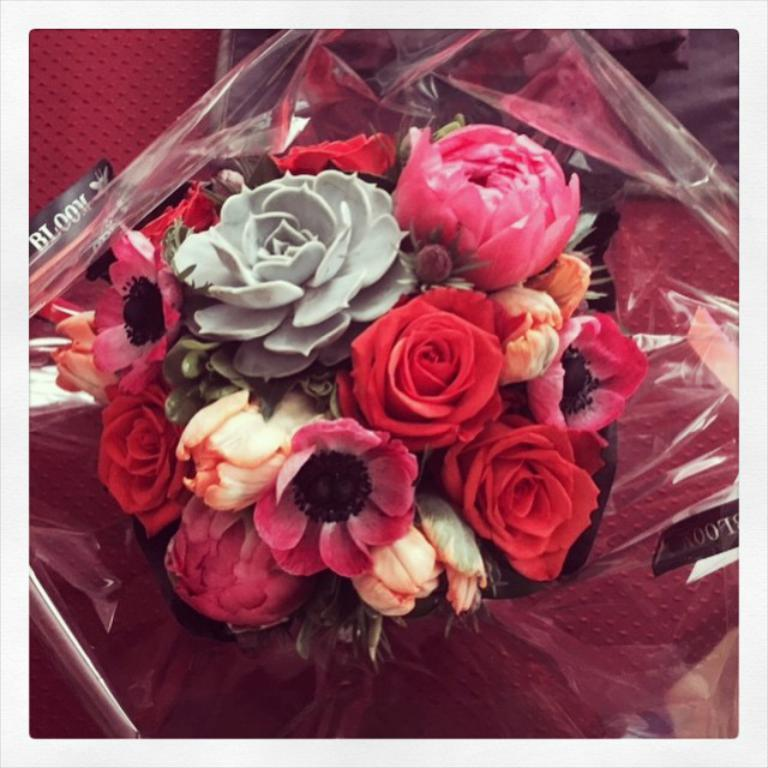What is the main subject of the image? There is a flower bouquet in the image. What is located behind the bouquet? There is a plastic cover behind the bouquet. Can you describe the possible location of the bouquet? The bouquet might be placed on a red color chair. What is the color of the background in the image? The background of the image appears to be red in color. What type of behavior does the sugar exhibit in the image? There is no sugar present in the image, so its behavior cannot be observed. 